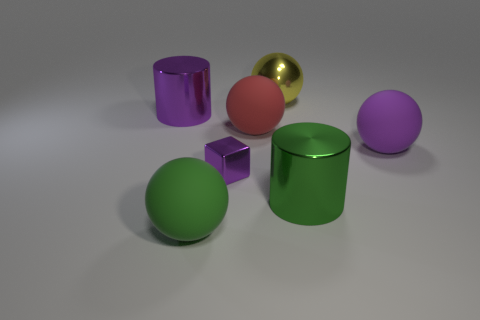What materials might these objects be made from based on their appearances? The objects in the image could be made from various materials. The shiny gold sphere looks metallic, possibly brass or gold-plated, while the matte-colored objects could be made of painted plastic or ceramics, given their less reflective surfaces. 